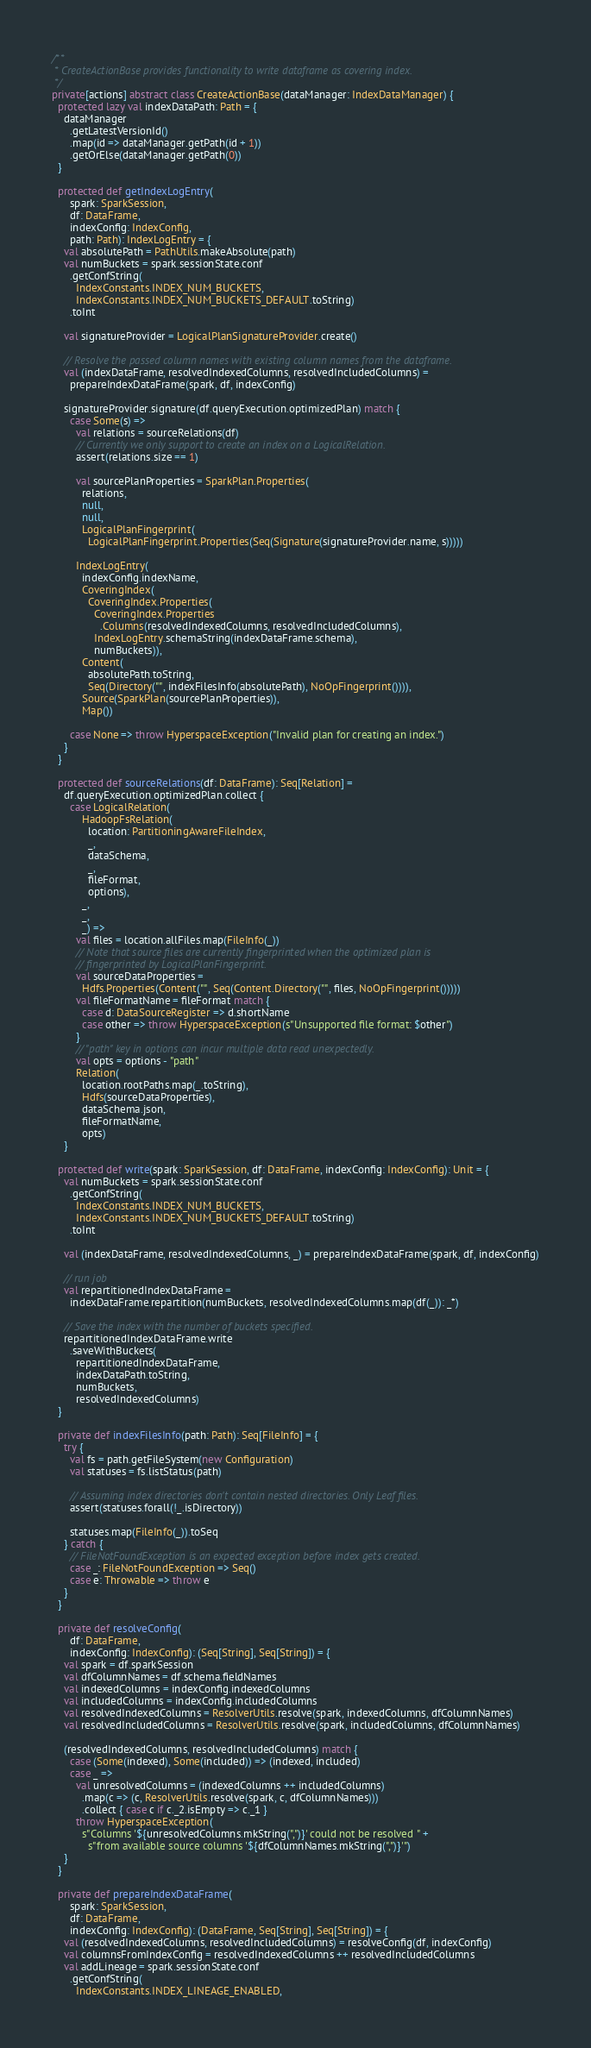<code> <loc_0><loc_0><loc_500><loc_500><_Scala_>
/**
 * CreateActionBase provides functionality to write dataframe as covering index.
 */
private[actions] abstract class CreateActionBase(dataManager: IndexDataManager) {
  protected lazy val indexDataPath: Path = {
    dataManager
      .getLatestVersionId()
      .map(id => dataManager.getPath(id + 1))
      .getOrElse(dataManager.getPath(0))
  }

  protected def getIndexLogEntry(
      spark: SparkSession,
      df: DataFrame,
      indexConfig: IndexConfig,
      path: Path): IndexLogEntry = {
    val absolutePath = PathUtils.makeAbsolute(path)
    val numBuckets = spark.sessionState.conf
      .getConfString(
        IndexConstants.INDEX_NUM_BUCKETS,
        IndexConstants.INDEX_NUM_BUCKETS_DEFAULT.toString)
      .toInt

    val signatureProvider = LogicalPlanSignatureProvider.create()

    // Resolve the passed column names with existing column names from the dataframe.
    val (indexDataFrame, resolvedIndexedColumns, resolvedIncludedColumns) =
      prepareIndexDataFrame(spark, df, indexConfig)

    signatureProvider.signature(df.queryExecution.optimizedPlan) match {
      case Some(s) =>
        val relations = sourceRelations(df)
        // Currently we only support to create an index on a LogicalRelation.
        assert(relations.size == 1)

        val sourcePlanProperties = SparkPlan.Properties(
          relations,
          null,
          null,
          LogicalPlanFingerprint(
            LogicalPlanFingerprint.Properties(Seq(Signature(signatureProvider.name, s)))))

        IndexLogEntry(
          indexConfig.indexName,
          CoveringIndex(
            CoveringIndex.Properties(
              CoveringIndex.Properties
                .Columns(resolvedIndexedColumns, resolvedIncludedColumns),
              IndexLogEntry.schemaString(indexDataFrame.schema),
              numBuckets)),
          Content(
            absolutePath.toString,
            Seq(Directory("", indexFilesInfo(absolutePath), NoOpFingerprint()))),
          Source(SparkPlan(sourcePlanProperties)),
          Map())

      case None => throw HyperspaceException("Invalid plan for creating an index.")
    }
  }

  protected def sourceRelations(df: DataFrame): Seq[Relation] =
    df.queryExecution.optimizedPlan.collect {
      case LogicalRelation(
          HadoopFsRelation(
            location: PartitioningAwareFileIndex,
            _,
            dataSchema,
            _,
            fileFormat,
            options),
          _,
          _,
          _) =>
        val files = location.allFiles.map(FileInfo(_))
        // Note that source files are currently fingerprinted when the optimized plan is
        // fingerprinted by LogicalPlanFingerprint.
        val sourceDataProperties =
          Hdfs.Properties(Content("", Seq(Content.Directory("", files, NoOpFingerprint()))))
        val fileFormatName = fileFormat match {
          case d: DataSourceRegister => d.shortName
          case other => throw HyperspaceException(s"Unsupported file format: $other")
        }
        // "path" key in options can incur multiple data read unexpectedly.
        val opts = options - "path"
        Relation(
          location.rootPaths.map(_.toString),
          Hdfs(sourceDataProperties),
          dataSchema.json,
          fileFormatName,
          opts)
    }

  protected def write(spark: SparkSession, df: DataFrame, indexConfig: IndexConfig): Unit = {
    val numBuckets = spark.sessionState.conf
      .getConfString(
        IndexConstants.INDEX_NUM_BUCKETS,
        IndexConstants.INDEX_NUM_BUCKETS_DEFAULT.toString)
      .toInt

    val (indexDataFrame, resolvedIndexedColumns, _) = prepareIndexDataFrame(spark, df, indexConfig)

    // run job
    val repartitionedIndexDataFrame =
      indexDataFrame.repartition(numBuckets, resolvedIndexedColumns.map(df(_)): _*)

    // Save the index with the number of buckets specified.
    repartitionedIndexDataFrame.write
      .saveWithBuckets(
        repartitionedIndexDataFrame,
        indexDataPath.toString,
        numBuckets,
        resolvedIndexedColumns)
  }

  private def indexFilesInfo(path: Path): Seq[FileInfo] = {
    try {
      val fs = path.getFileSystem(new Configuration)
      val statuses = fs.listStatus(path)

      // Assuming index directories don't contain nested directories. Only Leaf files.
      assert(statuses.forall(!_.isDirectory))

      statuses.map(FileInfo(_)).toSeq
    } catch {
      // FileNotFoundException is an expected exception before index gets created.
      case _: FileNotFoundException => Seq()
      case e: Throwable => throw e
    }
  }

  private def resolveConfig(
      df: DataFrame,
      indexConfig: IndexConfig): (Seq[String], Seq[String]) = {
    val spark = df.sparkSession
    val dfColumnNames = df.schema.fieldNames
    val indexedColumns = indexConfig.indexedColumns
    val includedColumns = indexConfig.includedColumns
    val resolvedIndexedColumns = ResolverUtils.resolve(spark, indexedColumns, dfColumnNames)
    val resolvedIncludedColumns = ResolverUtils.resolve(spark, includedColumns, dfColumnNames)

    (resolvedIndexedColumns, resolvedIncludedColumns) match {
      case (Some(indexed), Some(included)) => (indexed, included)
      case _ =>
        val unresolvedColumns = (indexedColumns ++ includedColumns)
          .map(c => (c, ResolverUtils.resolve(spark, c, dfColumnNames)))
          .collect { case c if c._2.isEmpty => c._1 }
        throw HyperspaceException(
          s"Columns '${unresolvedColumns.mkString(",")}' could not be resolved " +
            s"from available source columns '${dfColumnNames.mkString(",")}'")
    }
  }

  private def prepareIndexDataFrame(
      spark: SparkSession,
      df: DataFrame,
      indexConfig: IndexConfig): (DataFrame, Seq[String], Seq[String]) = {
    val (resolvedIndexedColumns, resolvedIncludedColumns) = resolveConfig(df, indexConfig)
    val columnsFromIndexConfig = resolvedIndexedColumns ++ resolvedIncludedColumns
    val addLineage = spark.sessionState.conf
      .getConfString(
        IndexConstants.INDEX_LINEAGE_ENABLED,</code> 